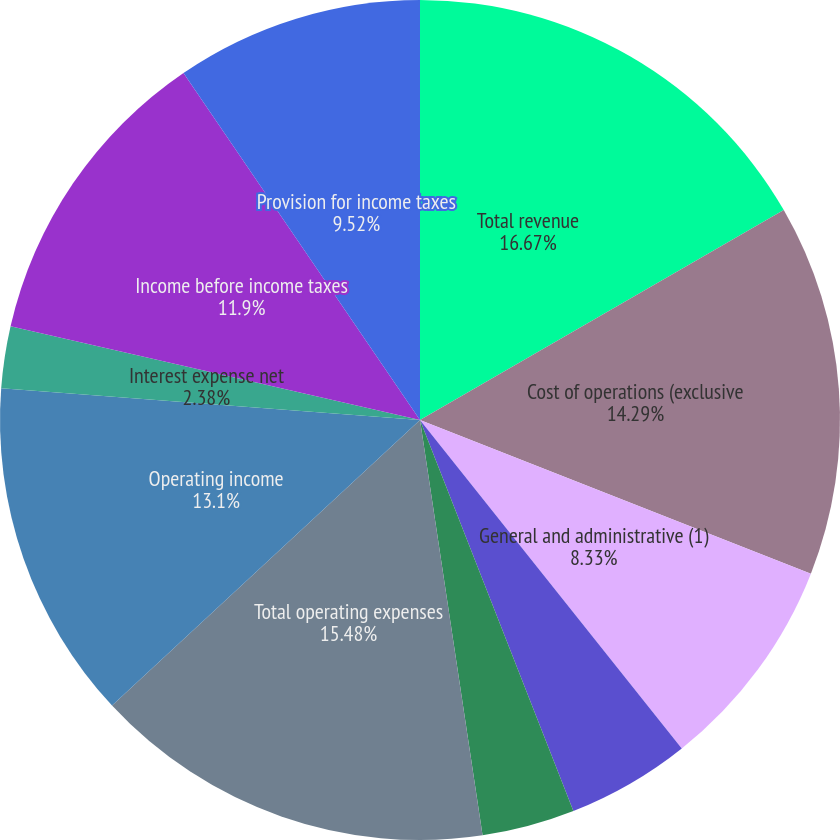Convert chart to OTSL. <chart><loc_0><loc_0><loc_500><loc_500><pie_chart><fcel>Total revenue<fcel>Cost of operations (exclusive<fcel>General and administrative (1)<fcel>Depreciation and other<fcel>Amortization of purchased<fcel>Total operating expenses<fcel>Operating income<fcel>Interest expense net<fcel>Income before income taxes<fcel>Provision for income taxes<nl><fcel>16.67%<fcel>14.29%<fcel>8.33%<fcel>4.76%<fcel>3.57%<fcel>15.48%<fcel>13.1%<fcel>2.38%<fcel>11.9%<fcel>9.52%<nl></chart> 